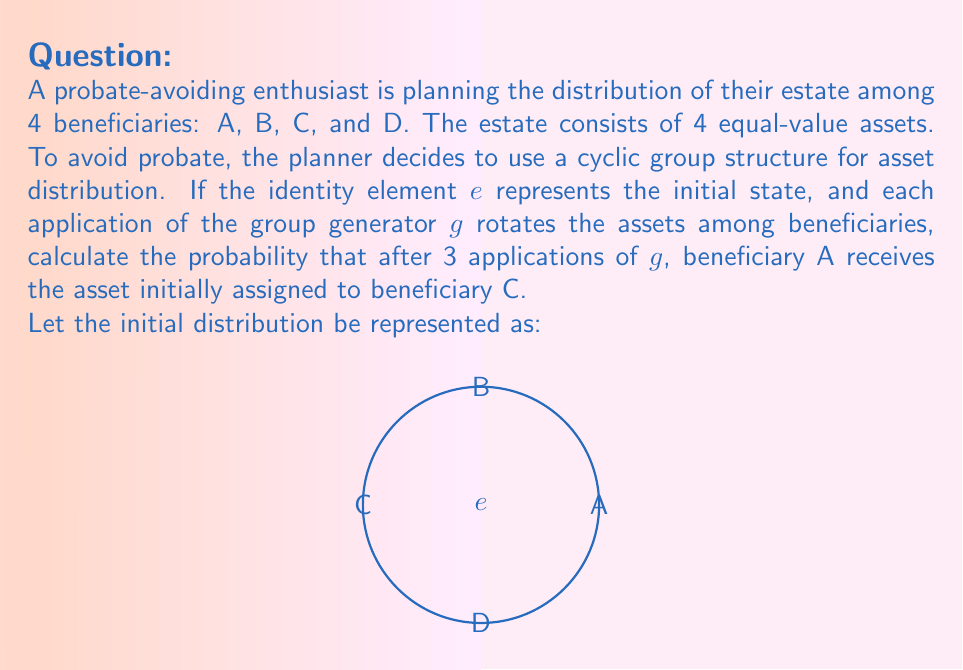What is the answer to this math problem? Let's approach this step-by-step using group theory:

1) The cyclic group of order 4 is isomorphic to $\mathbb{Z}_4$ under addition modulo 4.

2) Let's assign numbers to beneficiaries: A = 0, B = 1, C = 2, D = 3.

3) The generator g acts as a rotation, which can be represented as adding 1 (mod 4).

4) Initially, C has the asset at position 2.

5) After 3 applications of g, the asset moves:
   $2 \xrightarrow{+1} 3 \xrightarrow{+1} 0 \xrightarrow{+1} 1$ (all mod 4)

6) The final position is 1, which corresponds to beneficiary B, not A.

7) In fact, for A to receive C's initial asset, we would need:
   $2 + x \equiv 0 \pmod{4}$
   where x is the number of applications of g.

8) This equation has a unique solution: $x \equiv 2 \pmod{4}$

9) Therefore, there is no way for A to receive C's asset after exactly 3 applications of g.

10) The probability is thus 0.
Answer: 0 